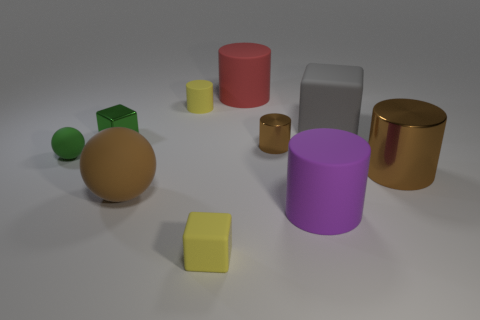Can you tell me about the objects on the left side of the image? On the left side, you'll notice two spheres and a cube. The smaller sphere and the cube are both green, suggesting they might be part of a set, while the larger sphere is beige. 